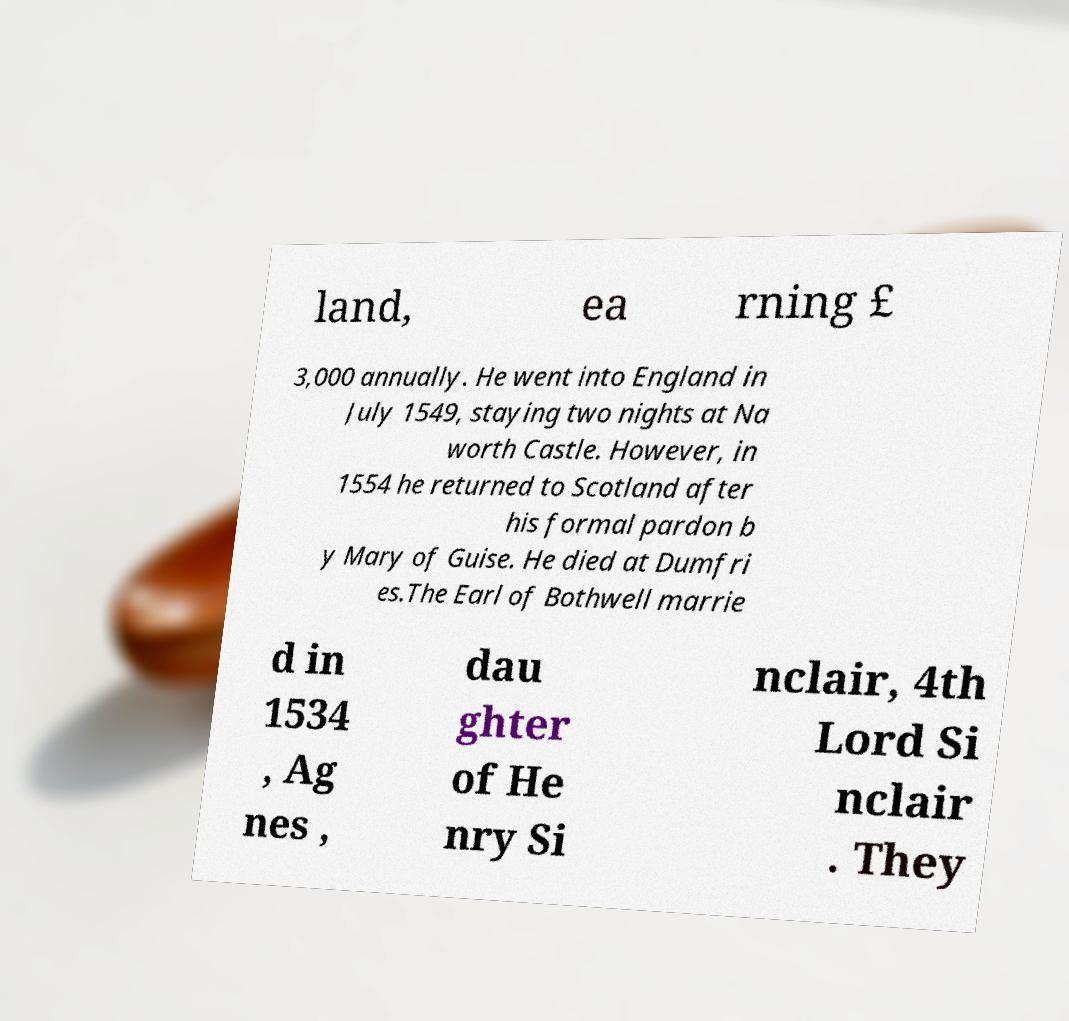Could you assist in decoding the text presented in this image and type it out clearly? land, ea rning £ 3,000 annually. He went into England in July 1549, staying two nights at Na worth Castle. However, in 1554 he returned to Scotland after his formal pardon b y Mary of Guise. He died at Dumfri es.The Earl of Bothwell marrie d in 1534 , Ag nes , dau ghter of He nry Si nclair, 4th Lord Si nclair . They 